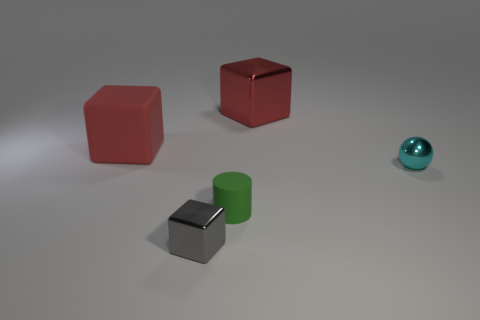Add 1 small cyan spheres. How many objects exist? 6 Subtract all cubes. How many objects are left? 2 Add 5 big yellow blocks. How many big yellow blocks exist? 5 Subtract 0 brown cylinders. How many objects are left? 5 Subtract all large purple metal objects. Subtract all metallic objects. How many objects are left? 2 Add 4 small cyan metal balls. How many small cyan metal balls are left? 5 